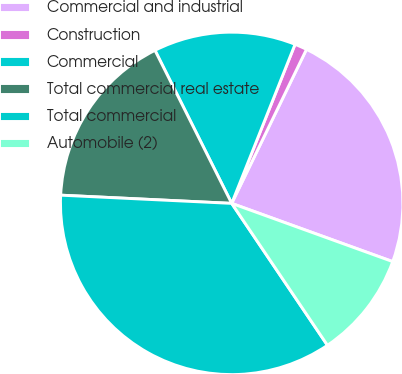<chart> <loc_0><loc_0><loc_500><loc_500><pie_chart><fcel>Commercial and industrial<fcel>Construction<fcel>Commercial<fcel>Total commercial real estate<fcel>Total commercial<fcel>Automobile (2)<nl><fcel>23.33%<fcel>1.16%<fcel>13.43%<fcel>16.84%<fcel>35.21%<fcel>10.03%<nl></chart> 